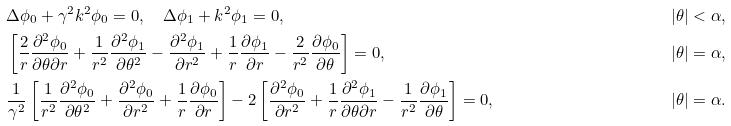<formula> <loc_0><loc_0><loc_500><loc_500>& \Delta \phi _ { 0 } + \gamma ^ { 2 } k ^ { 2 } \phi _ { 0 } = 0 , \quad \Delta \phi _ { 1 } + k ^ { 2 } \phi _ { 1 } = 0 , \quad & | \theta | < \alpha , \\ & \left [ \frac { 2 } { r } \frac { \partial ^ { 2 } \phi _ { 0 } } { \partial \theta \partial r } + \frac { 1 } { r ^ { 2 } } \frac { \partial ^ { 2 } \phi _ { 1 } } { \partial \theta ^ { 2 } } - \frac { \partial ^ { 2 } \phi _ { 1 } } { \partial r ^ { 2 } } + \frac { 1 } { r } \frac { \partial \phi _ { 1 } } { \partial r } - \frac { 2 } { r ^ { 2 } } \frac { \partial \phi _ { 0 } } { \partial \theta } \right ] = 0 , \ \quad & | \theta | = \alpha , \\ & \frac { 1 } { \gamma ^ { 2 } } \left [ \frac { 1 } { r ^ { 2 } } \frac { \partial ^ { 2 } \phi _ { 0 } } { \partial \theta ^ { 2 } } + \frac { \partial ^ { 2 } \phi _ { 0 } } { \partial r ^ { 2 } } + \frac { 1 } { r } \frac { \partial \phi _ { 0 } } { \partial r } \right ] - 2 \left [ \frac { \partial ^ { 2 } \phi _ { 0 } } { \partial r ^ { 2 } } + \frac { 1 } { r } \frac { \partial ^ { 2 } \phi _ { 1 } } { \partial \theta \partial r } - \frac { 1 } { r ^ { 2 } } \frac { \partial \phi _ { 1 } } { \partial \theta } \right ] = 0 , \quad & | \theta | = \alpha .</formula> 